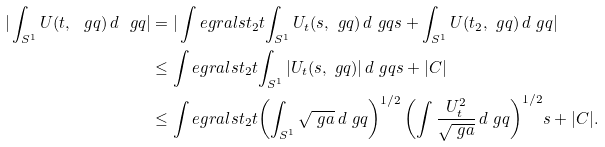Convert formula to latex. <formula><loc_0><loc_0><loc_500><loc_500>| \int _ { S ^ { 1 } } U ( t , \ g q ) \, d \ g q | & = | \int e g r a l s { t _ { 2 } } { t } { \int _ { S ^ { 1 } } U _ { t } ( s , \ g q ) \, d \ g q } { s } + \int _ { S ^ { 1 } } U ( t _ { 2 } , \ g q ) \, d \ g q | \\ & \leq \int e g r a l s { t _ { 2 } } { t } { \int _ { S ^ { 1 } } | U _ { t } ( s , \ g q ) | \, d \ g q } { s } + | C | \\ & \leq \int e g r a l s { t _ { 2 } } { t } { \left ( \int _ { S ^ { 1 } } \sqrt { \ g a } \, d \ g q \right ) ^ { 1 / 2 } \left ( \int \frac { U _ { t } ^ { 2 } } { \sqrt { \ g a } } \, d \ g q \right ) ^ { 1 / 2 } } { s } + | C | .</formula> 